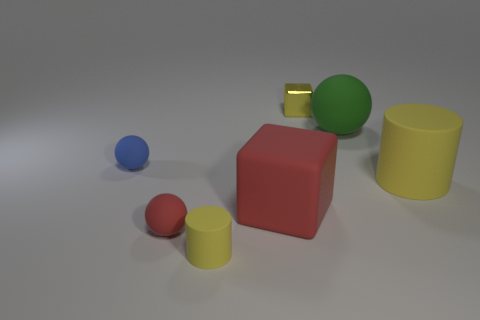What number of objects are in front of the small yellow block and behind the small blue sphere?
Offer a terse response. 1. What number of other things are there of the same shape as the small blue rubber thing?
Ensure brevity in your answer.  2. Is the number of small blue rubber things to the right of the green ball greater than the number of small yellow rubber cylinders?
Provide a succinct answer. No. There is a cylinder in front of the large red thing; what is its color?
Ensure brevity in your answer.  Yellow. There is a matte ball that is the same color as the large rubber cube; what size is it?
Ensure brevity in your answer.  Small. How many matte objects are either small green cylinders or small red objects?
Provide a succinct answer. 1. Is there a tiny metal block that is left of the large rubber object in front of the matte cylinder that is right of the big cube?
Your response must be concise. No. What number of spheres are left of the green ball?
Make the answer very short. 2. What is the material of the small cylinder that is the same color as the metal thing?
Provide a short and direct response. Rubber. What number of big objects are shiny cylinders or yellow cylinders?
Your response must be concise. 1. 